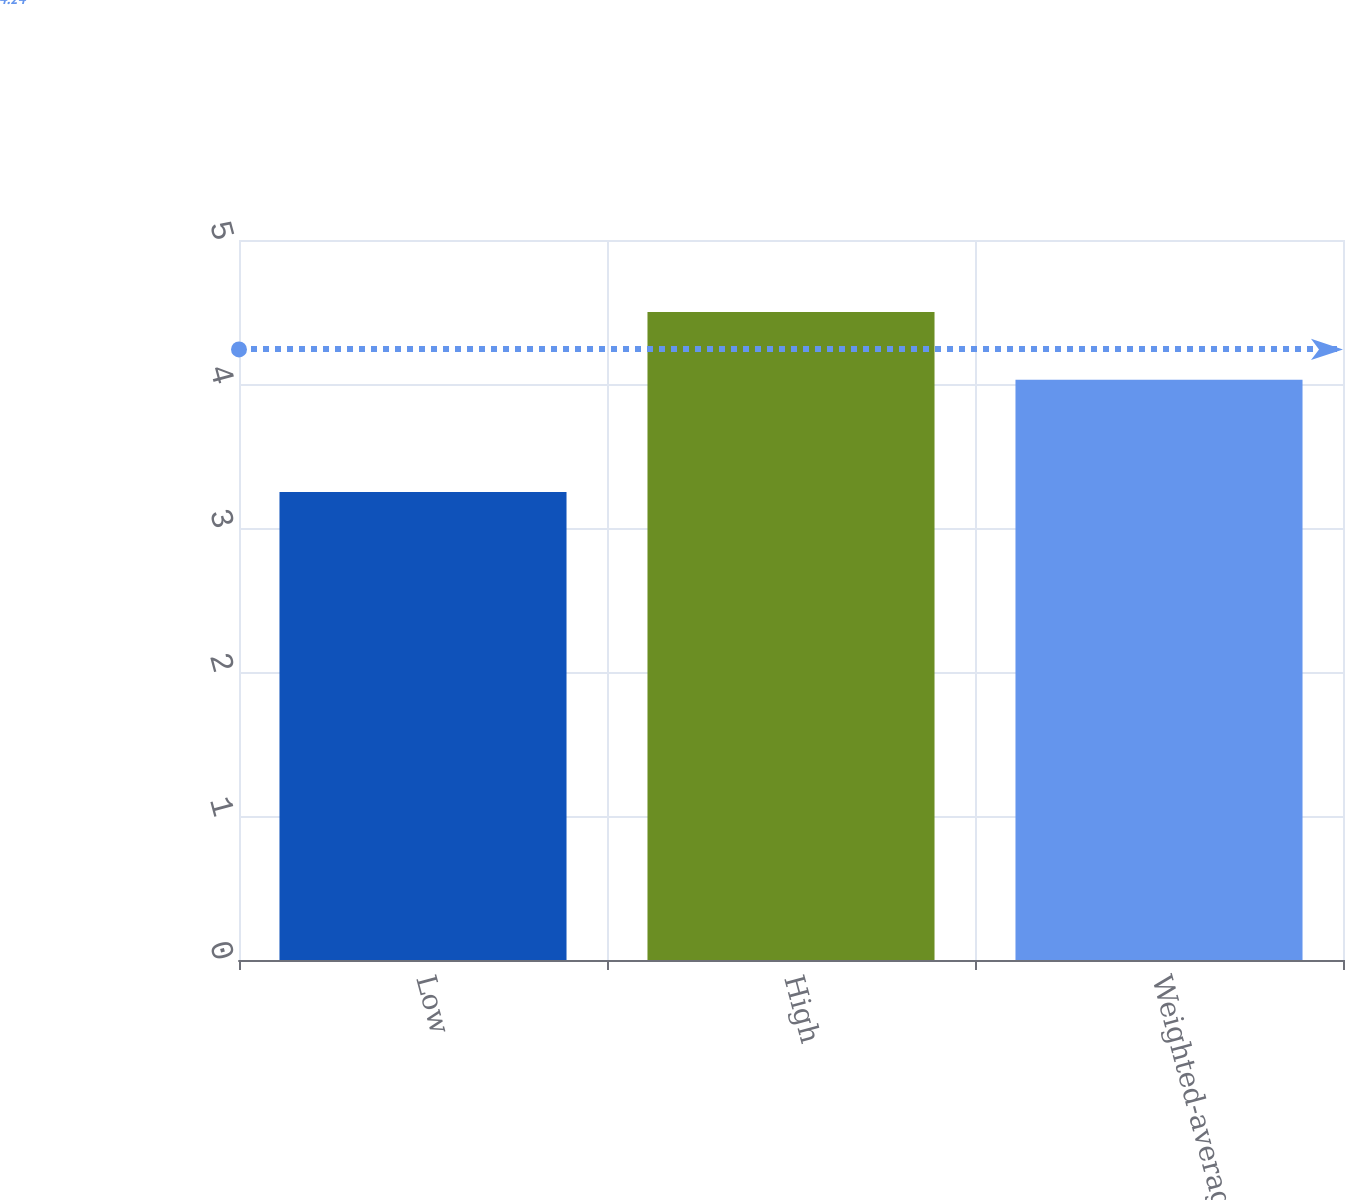Convert chart. <chart><loc_0><loc_0><loc_500><loc_500><bar_chart><fcel>Low<fcel>High<fcel>Weighted-average<nl><fcel>3.25<fcel>4.5<fcel>4.03<nl></chart> 